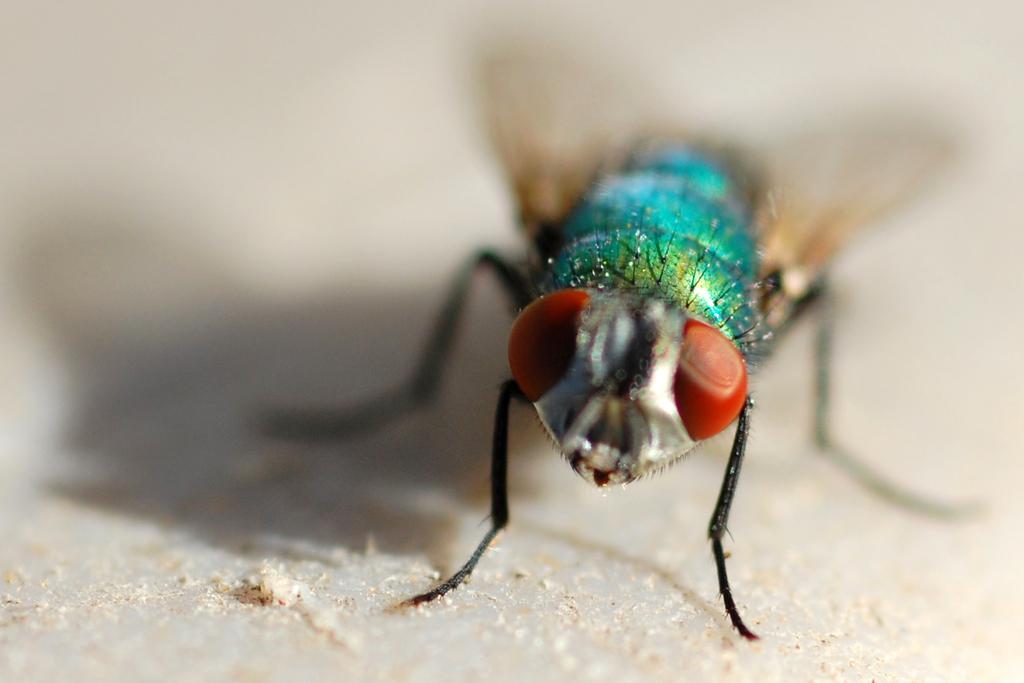In one or two sentences, can you explain what this image depicts? In this picture we can see an insect. 